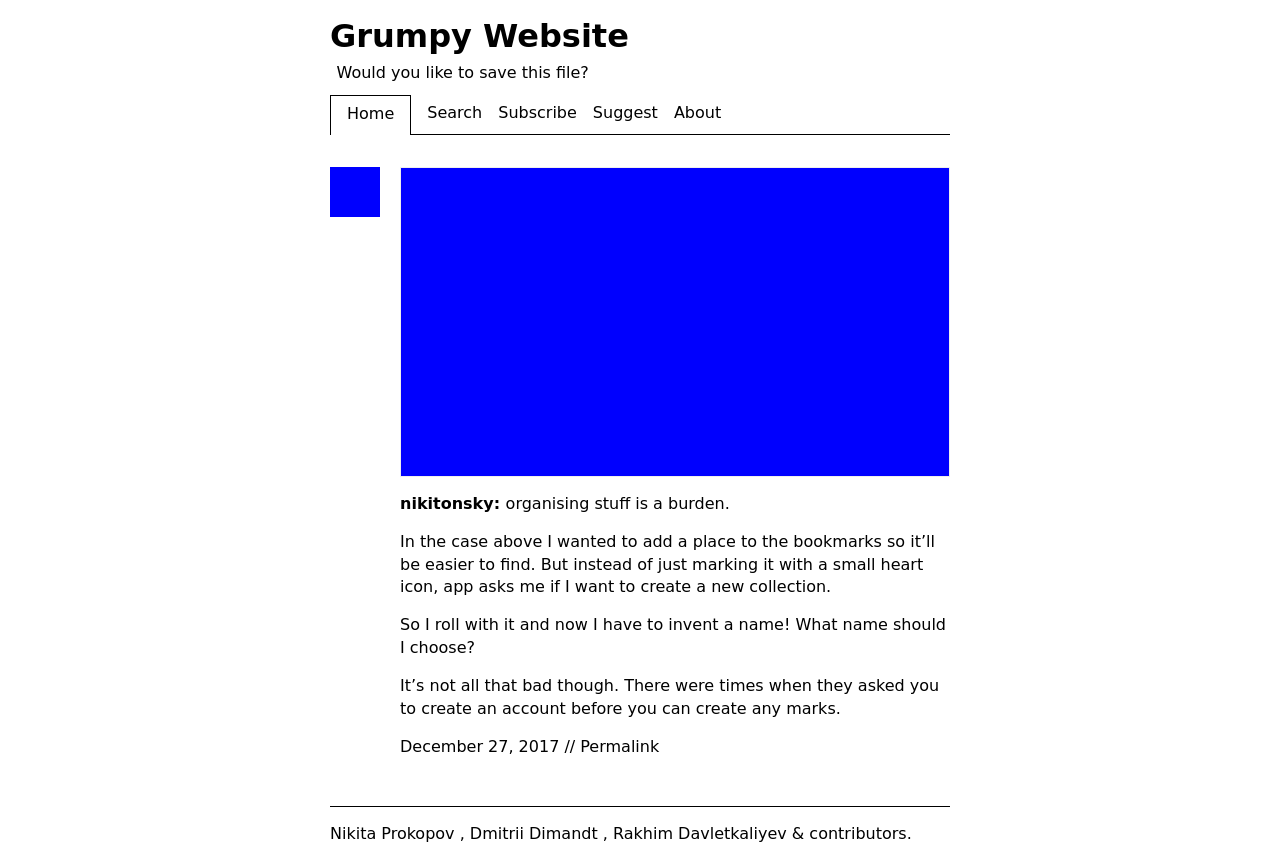Discuss the user experience implications of the features shown in the website image. The website appears user-friendly due to its clean layout and straightforward navigation. However, the author mentions a burden in organizing content, suggesting potential improvements in user interface design to make bookmarking more intuitive and less cumbersome. Enhancing features like bookmark creation with a simpler, one-click solution could enhance the overall user experience. 